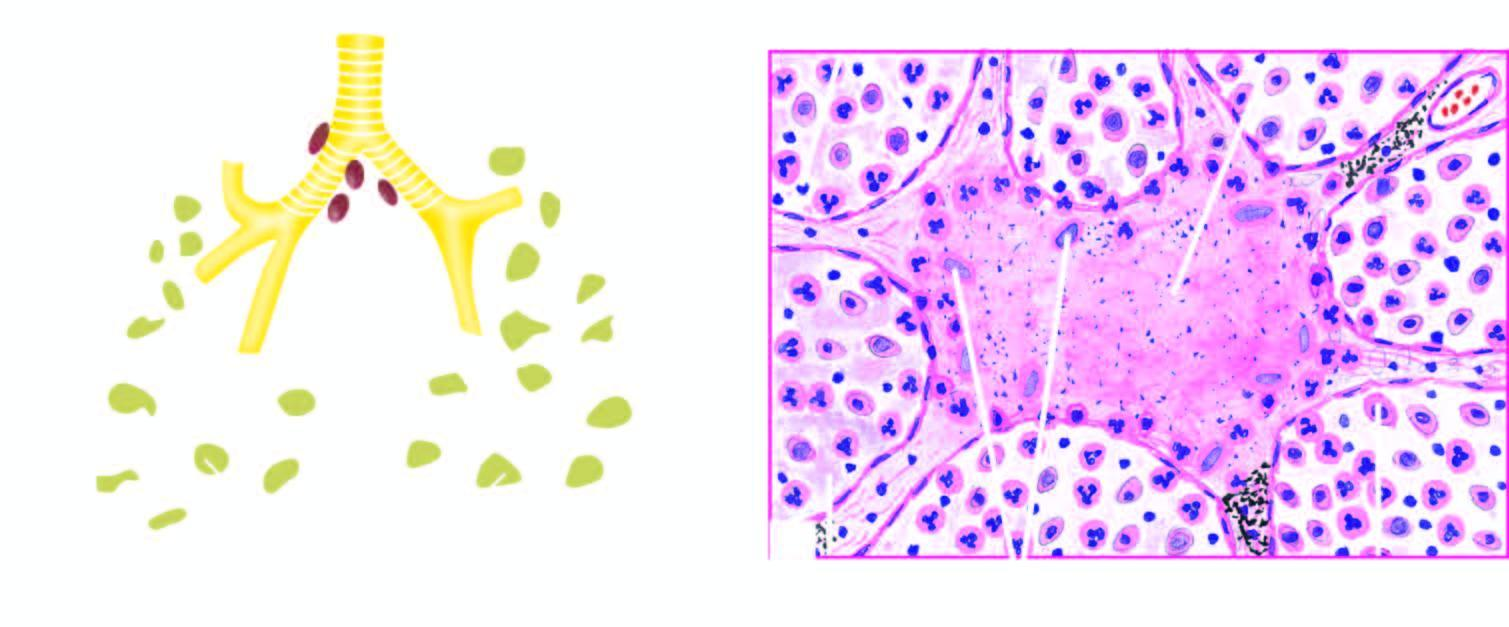what have numerous acid-fast bacilli not shown here in afb staining?
Answer the question using a single word or phrase. These cases 